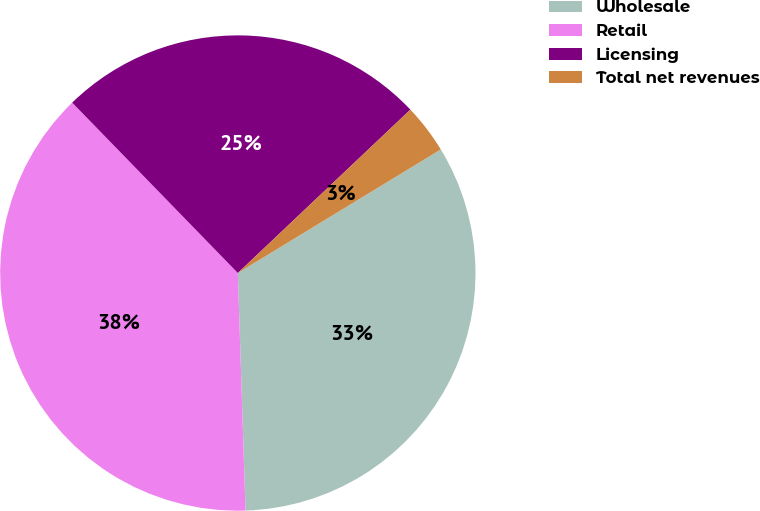Convert chart. <chart><loc_0><loc_0><loc_500><loc_500><pie_chart><fcel>Wholesale<fcel>Retail<fcel>Licensing<fcel>Total net revenues<nl><fcel>33.19%<fcel>38.24%<fcel>25.21%<fcel>3.36%<nl></chart> 